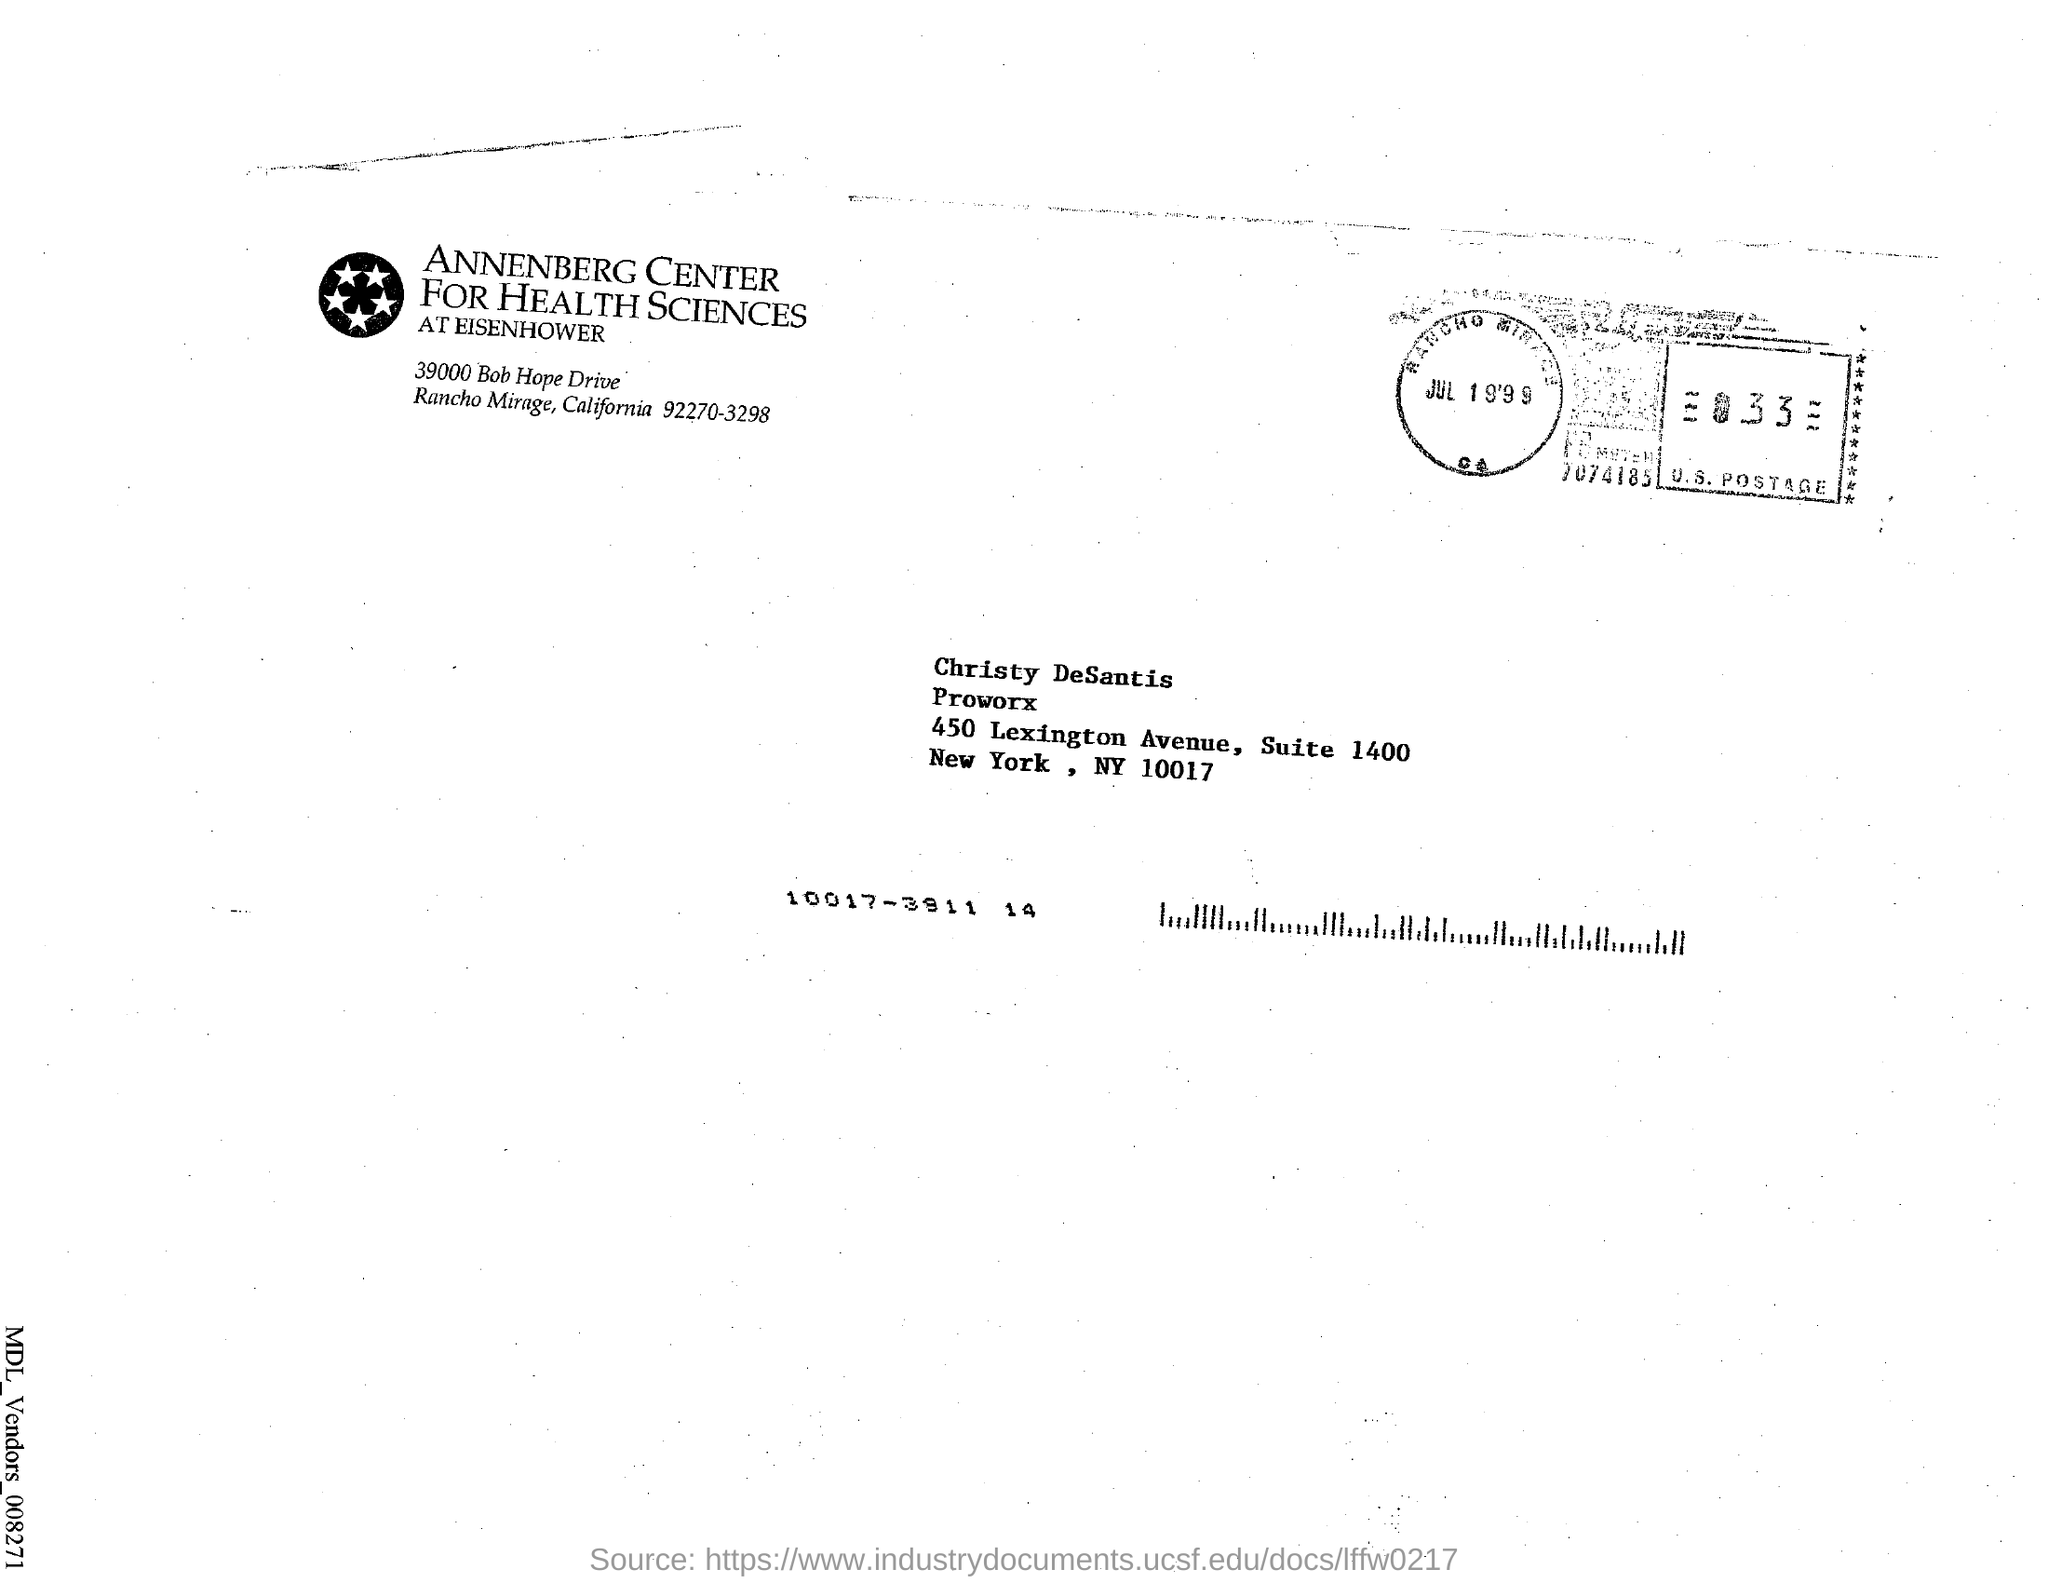Highlight a few significant elements in this photo. The date mentioned on the U.S. postage stamp is July 19th, 1999. The name appearing in the address is Christy DeSantis. 